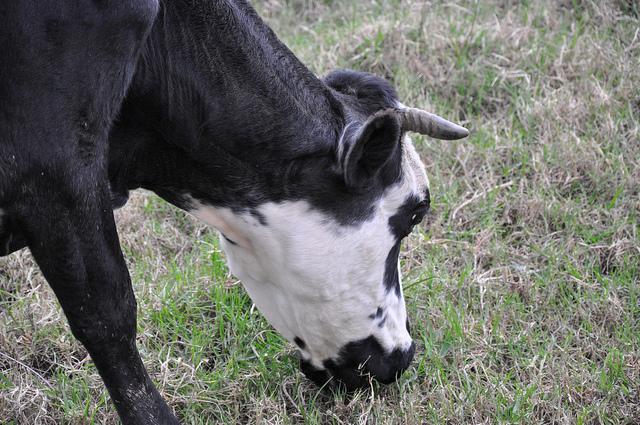How many cows are in this picture?
Give a very brief answer. 1. 